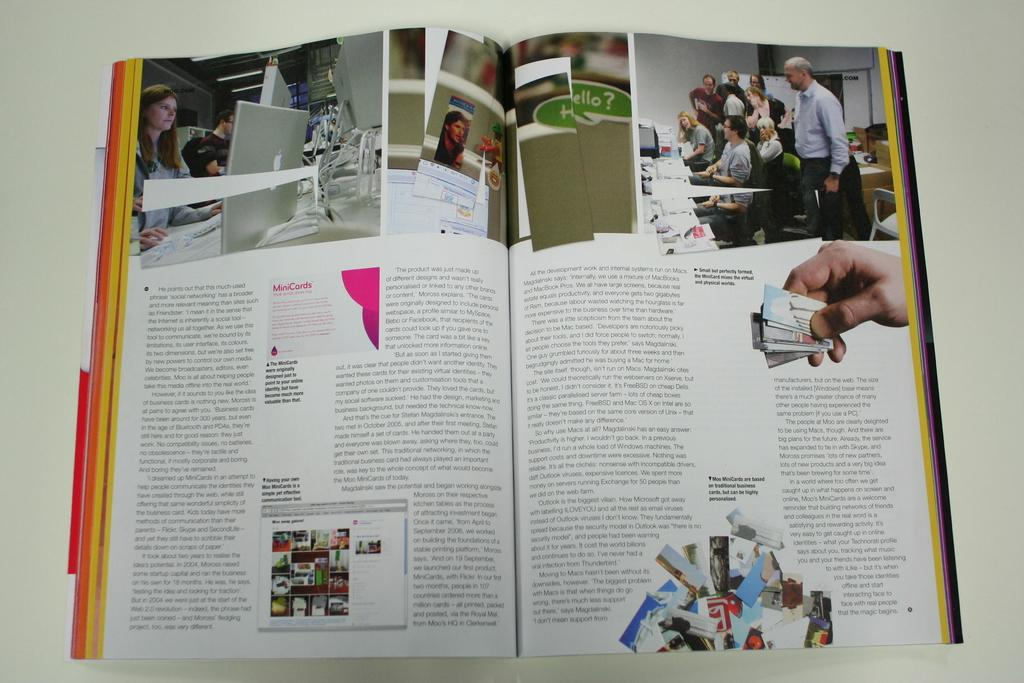<image>
Offer a succinct explanation of the picture presented. A magazine is opened up to an article that talks about the role that some forms of social media and technology can have on a business. 